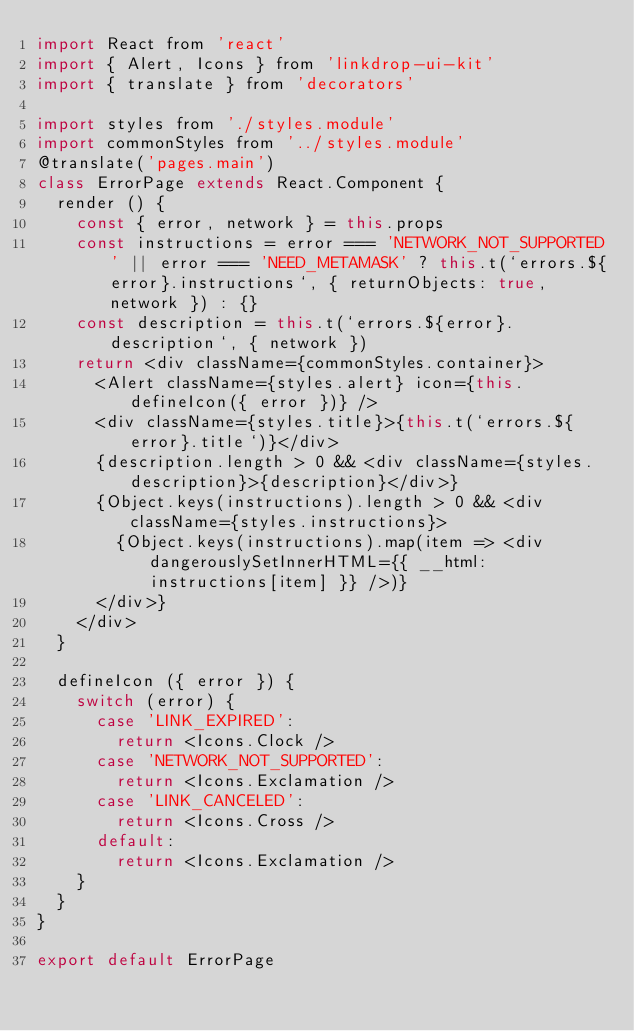Convert code to text. <code><loc_0><loc_0><loc_500><loc_500><_JavaScript_>import React from 'react'
import { Alert, Icons } from 'linkdrop-ui-kit'
import { translate } from 'decorators'

import styles from './styles.module'
import commonStyles from '../styles.module'
@translate('pages.main')
class ErrorPage extends React.Component {
  render () {
    const { error, network } = this.props
    const instructions = error === 'NETWORK_NOT_SUPPORTED' || error === 'NEED_METAMASK' ? this.t(`errors.${error}.instructions`, { returnObjects: true, network }) : {}
    const description = this.t(`errors.${error}.description`, { network })
    return <div className={commonStyles.container}>
      <Alert className={styles.alert} icon={this.defineIcon({ error })} />
      <div className={styles.title}>{this.t(`errors.${error}.title`)}</div>
      {description.length > 0 && <div className={styles.description}>{description}</div>}
      {Object.keys(instructions).length > 0 && <div className={styles.instructions}>
        {Object.keys(instructions).map(item => <div dangerouslySetInnerHTML={{ __html: instructions[item] }} />)}
      </div>}
    </div>
  }

  defineIcon ({ error }) {
    switch (error) {
      case 'LINK_EXPIRED':
        return <Icons.Clock />
      case 'NETWORK_NOT_SUPPORTED':
        return <Icons.Exclamation />
      case 'LINK_CANCELED':
        return <Icons.Cross />
      default:
        return <Icons.Exclamation />
    }
  }
}

export default ErrorPage
</code> 